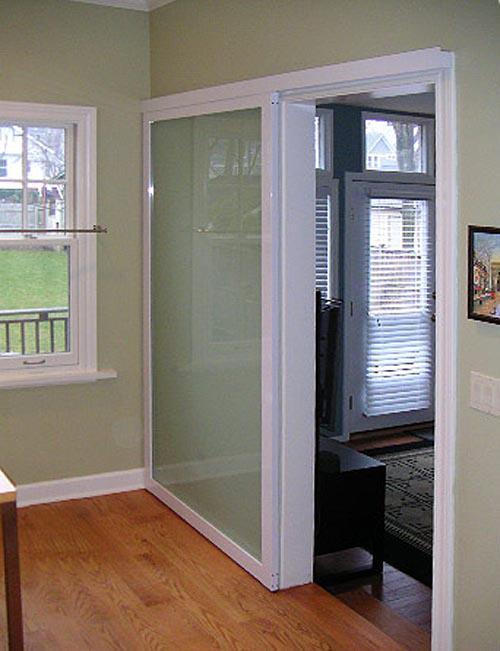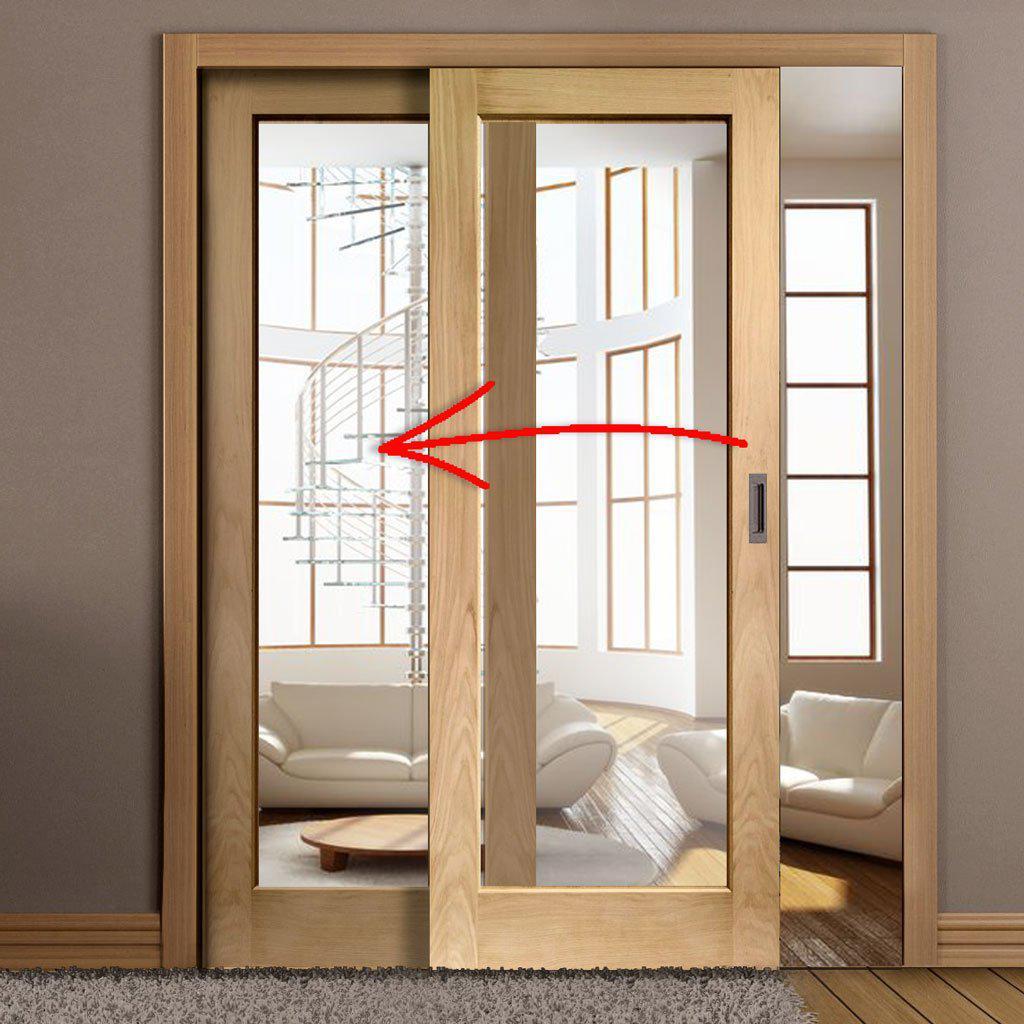The first image is the image on the left, the second image is the image on the right. For the images shown, is this caption "One image shows wooden sliding doors with overlapping semi-circle designs on them." true? Answer yes or no. No. The first image is the image on the left, the second image is the image on the right. Analyze the images presented: Is the assertion "There are two chairs in the image on the left." valid? Answer yes or no. No. 